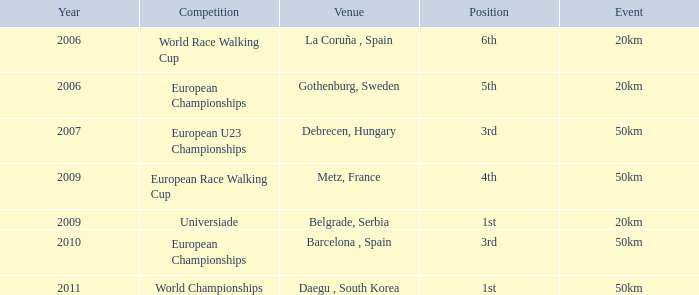What is the Position for the European U23 Championships? 3rd. 